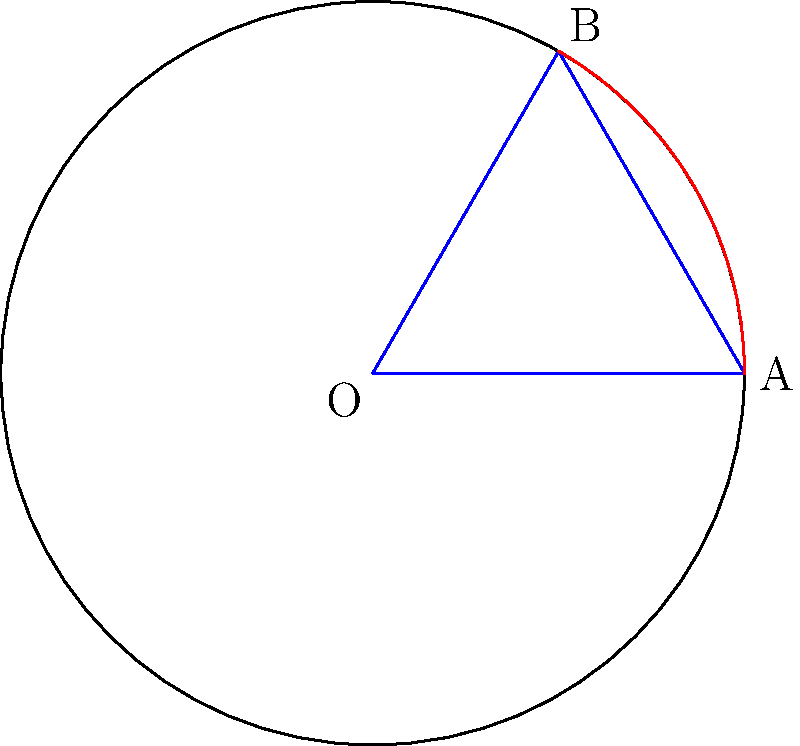As a pitcher, you're analyzing the trajectory of your curveball. The ball's path forms an arc of a circle with radius 60 feet (the distance from the pitcher's mound to home plate). If the central angle of this arc is 60°, what is the length of the arc representing the ball's curved path? Round your answer to the nearest foot. To solve this problem, we'll use the formula for arc length:

$s = r\theta$

Where:
$s$ = arc length
$r$ = radius of the circle
$\theta$ = central angle in radians

Step 1: Convert the angle from degrees to radians
$\theta = 60° \times \frac{\pi}{180°} = \frac{\pi}{3}$ radians

Step 2: Apply the arc length formula
$s = r\theta = 60 \times \frac{\pi}{3}$

Step 3: Simplify and calculate
$s = 20\pi \approx 62.83$ feet

Step 4: Round to the nearest foot
$62.83$ feet rounds to 63 feet

Therefore, the length of the arc representing the ball's curved path is approximately 63 feet.
Answer: 63 feet 